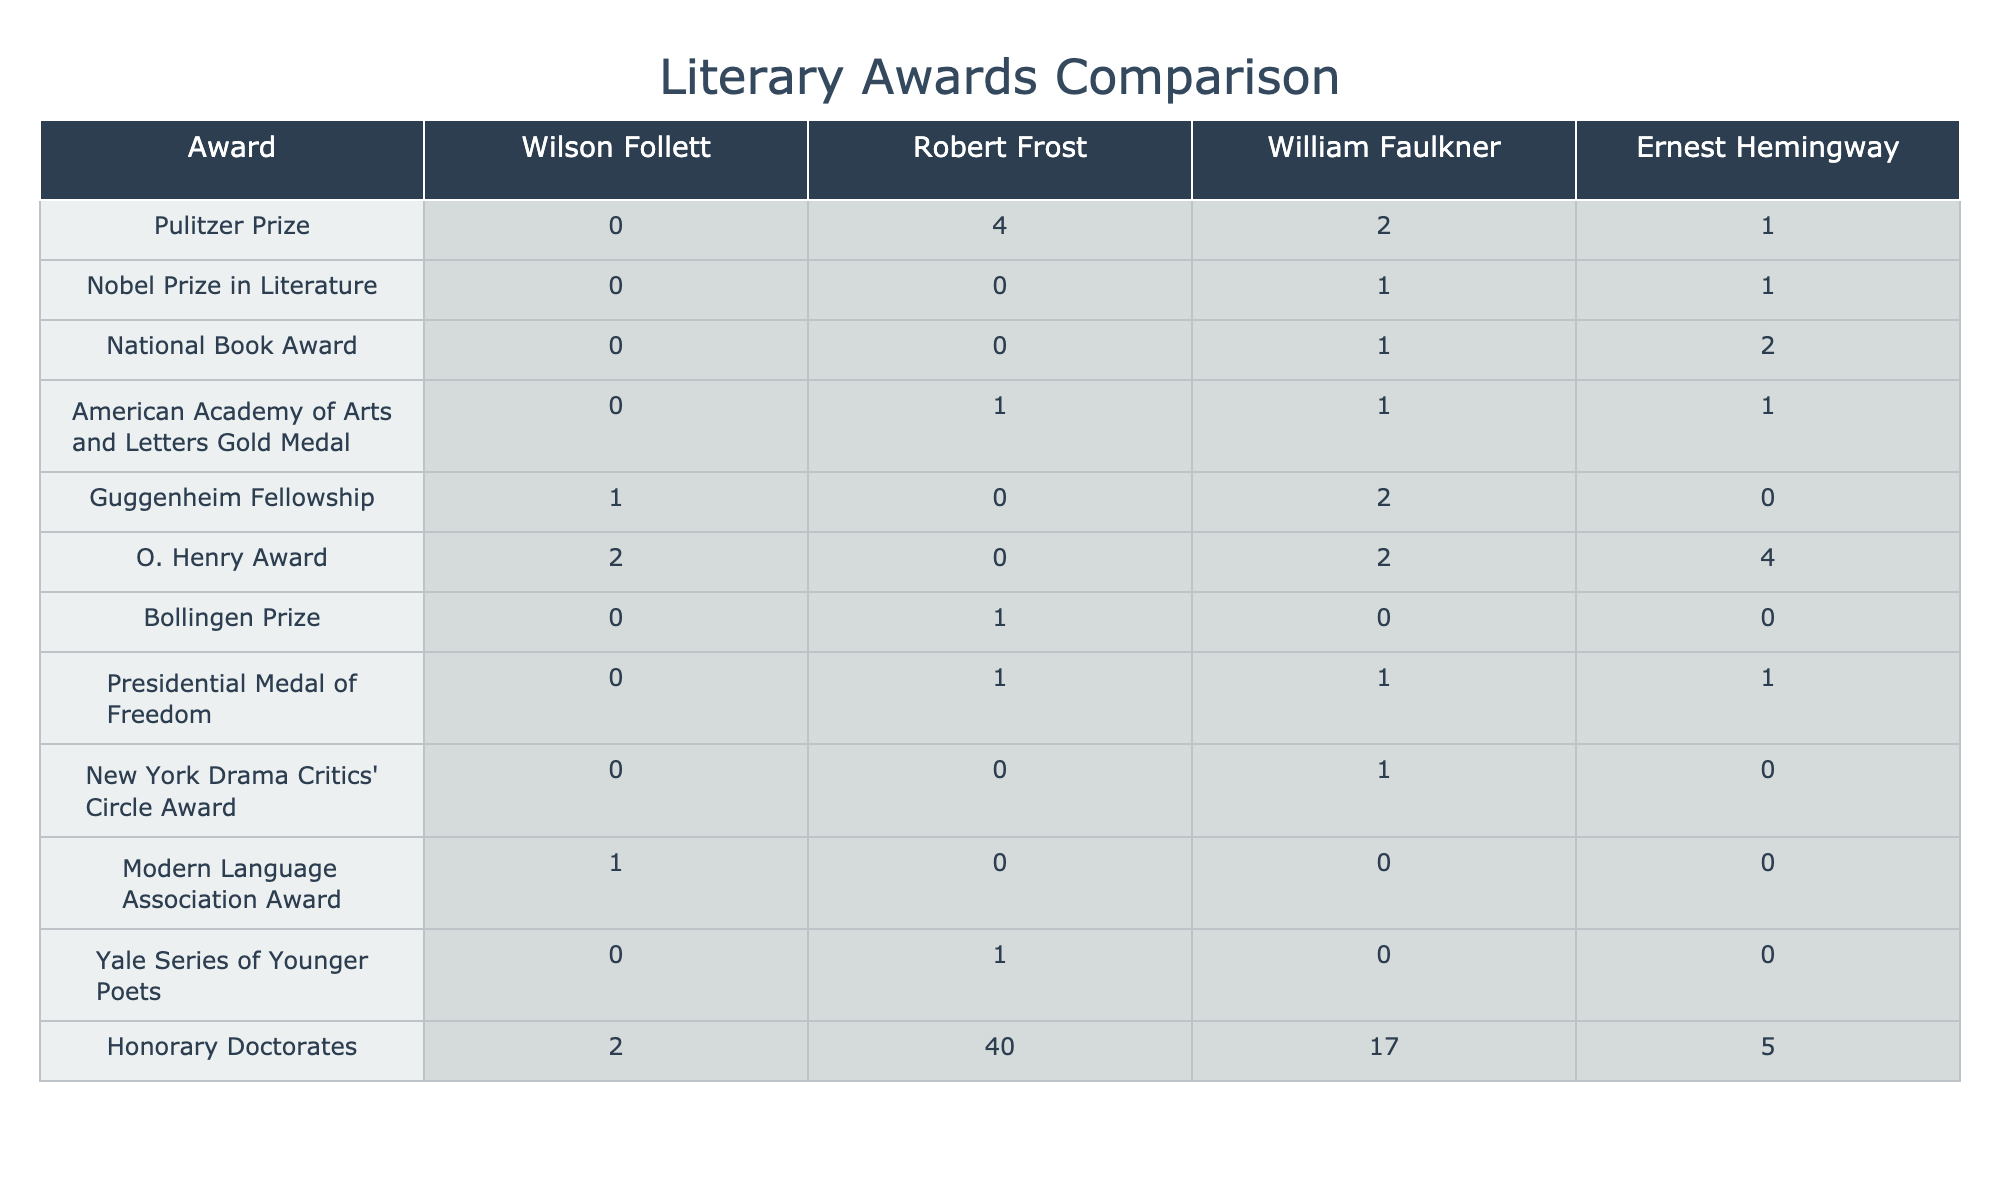What is the total number of Honorary Doctorates received by Wilson Follett? According to the table, Wilson Follett received a total of 2 Honorary Doctorates.
Answer: 2 How many O. Henry Awards does Ernest Hemingway have compared to Wilson Follett? Ernest Hemingway has 4 O. Henry Awards, while Wilson Follett has 2. So, Hemingway has 2 more O. Henry Awards than Follett.
Answer: 2 more Did Wilson Follett receive any Pulitzer Prizes? The table indicates that Wilson Follett received 0 Pulitzer Prizes.
Answer: No Among the writers listed, who has the highest number of Honorary Doctorates? By examining the table, Robert Frost has the highest number of Honorary Doctorates with a total of 40.
Answer: Robert Frost How many more Guggenheim Fellowships did William Faulkner receive than Wilson Follett? William Faulkner received 2 Guggenheim Fellowships while Wilson Follett received 1. The difference is 2 - 1 = 1.
Answer: 1 Is it true that Wilson Follett received more O. Henry Awards than Robert Frost? The table shows that Wilson Follett has 2 O. Henry Awards and Robert Frost has 0. Therefore, it is true that Follett received more O. Henry Awards.
Answer: Yes What is the average number of Awards received by each author across all categories? The total awards for each author are: Wilson Follett (5), Robert Frost (46), William Faulkner (6), and Ernest Hemingway (8). The sum is 65, and there are 4 authors, so the average is 65/4 = 16.25.
Answer: 16.25 Which author received the most awards for the categories listed in the table? Robert Frost received 46 awards in total, which is the highest compared to the others (Wilson Follett: 5, William Faulkner: 6, Ernest Hemingway: 8).
Answer: Robert Frost Did Wilson Follett win any Nobel Prizes in Literature? The table clearly shows that Wilson Follett received 0 Nobel Prizes in Literature.
Answer: No 